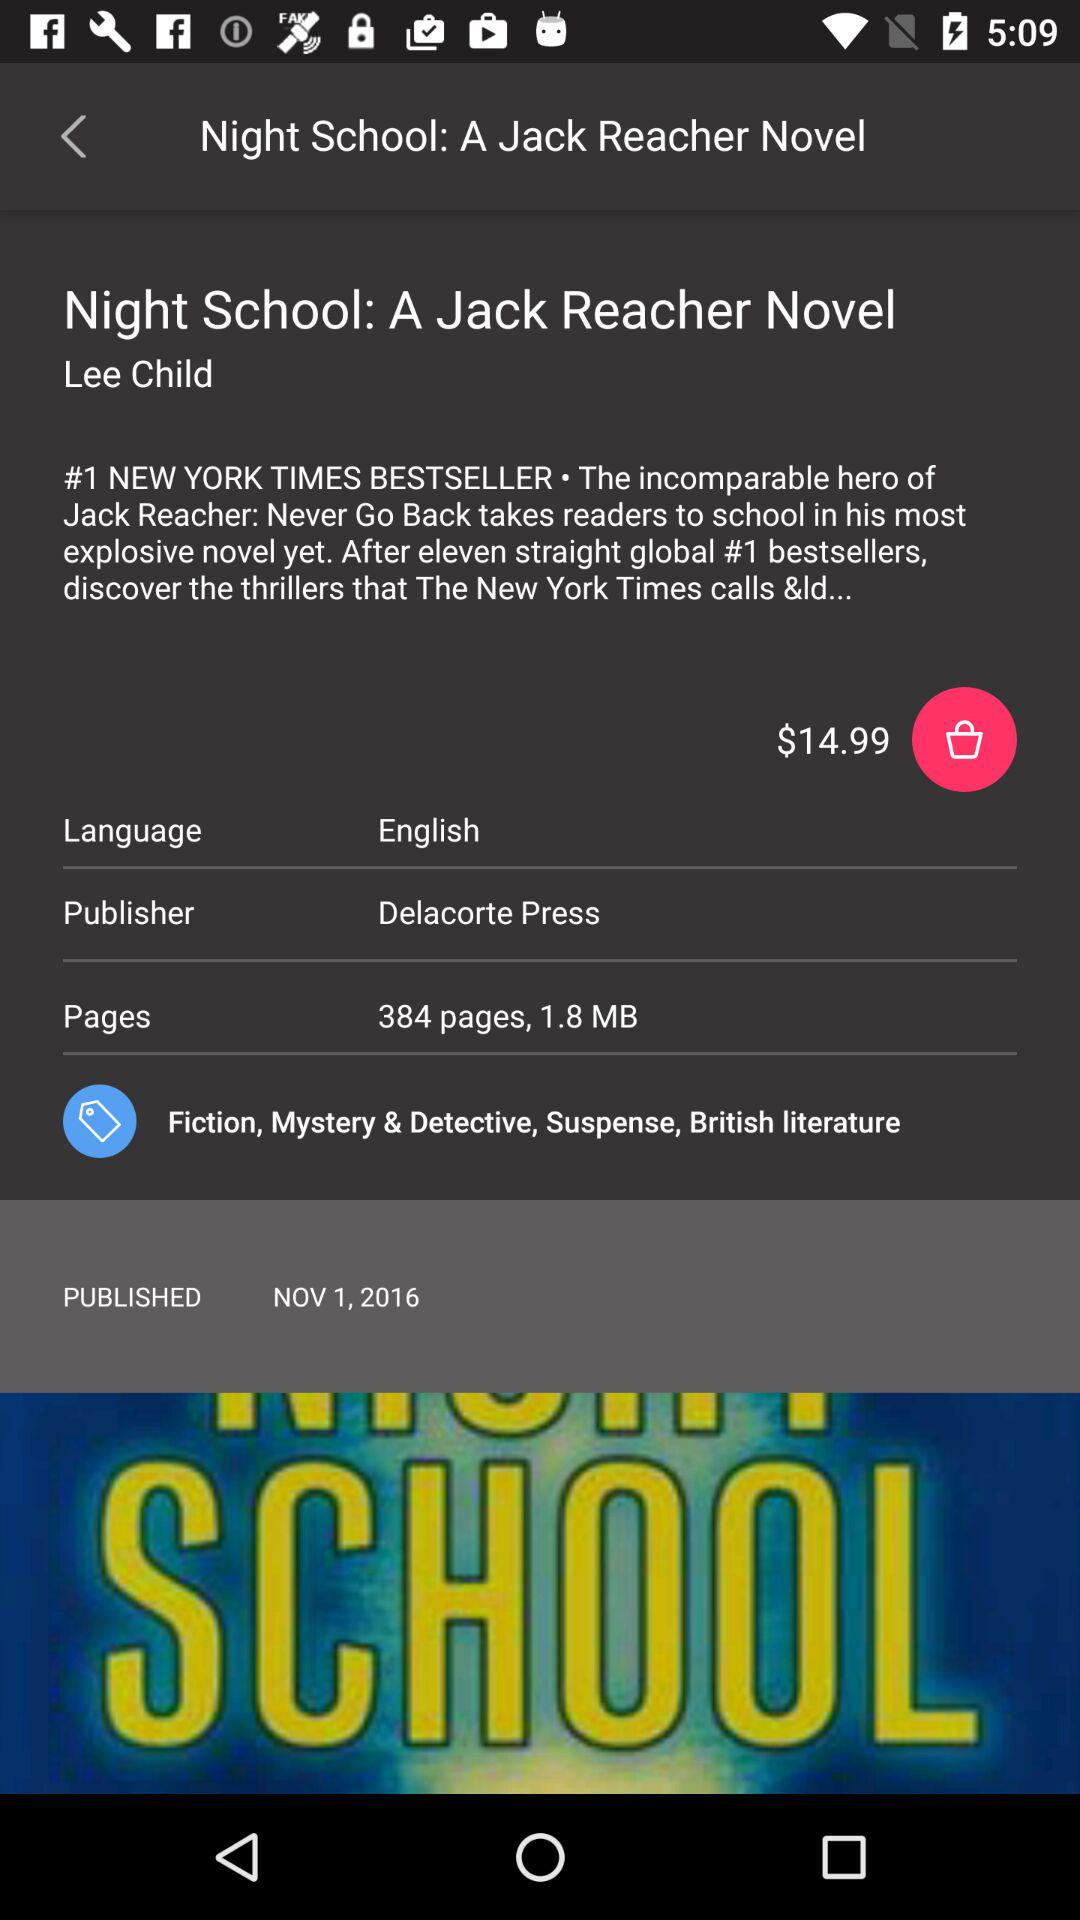How many pages are there? There are 384 pages. 